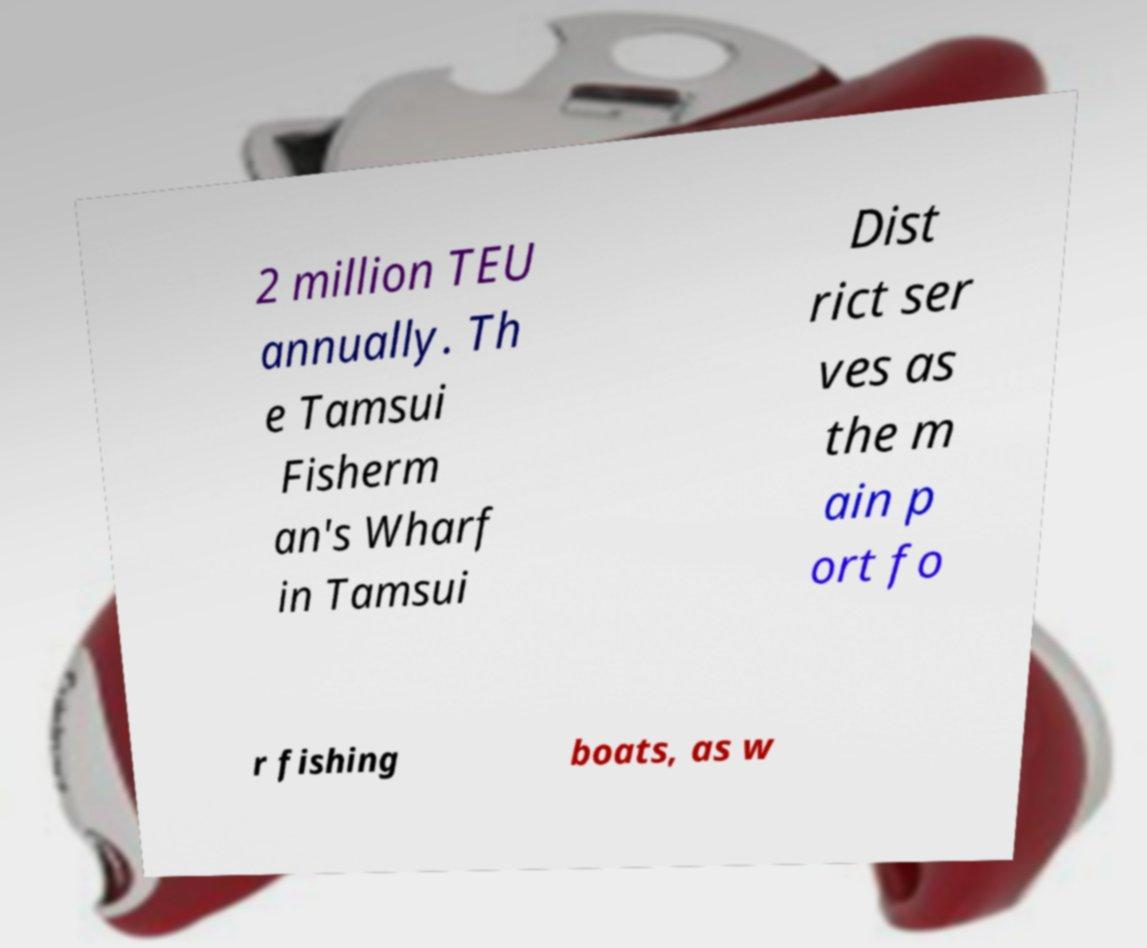There's text embedded in this image that I need extracted. Can you transcribe it verbatim? 2 million TEU annually. Th e Tamsui Fisherm an's Wharf in Tamsui Dist rict ser ves as the m ain p ort fo r fishing boats, as w 